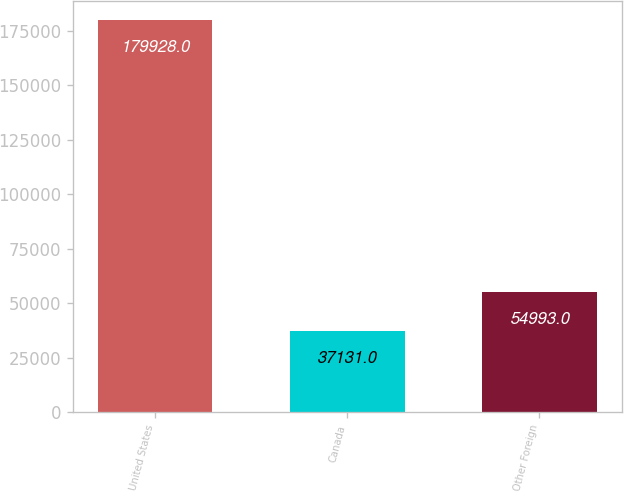<chart> <loc_0><loc_0><loc_500><loc_500><bar_chart><fcel>United States<fcel>Canada<fcel>Other Foreign<nl><fcel>179928<fcel>37131<fcel>54993<nl></chart> 